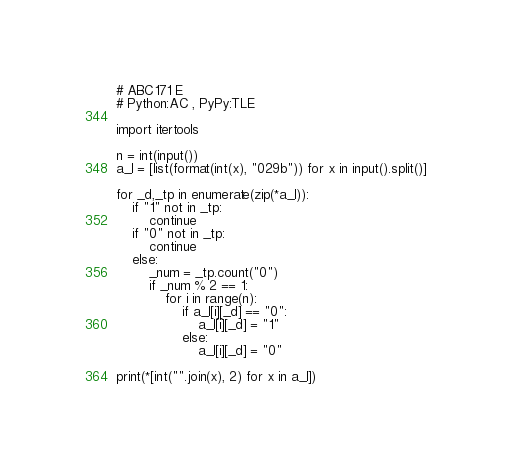Convert code to text. <code><loc_0><loc_0><loc_500><loc_500><_Python_># ABC171 E 
# Python:AC , PyPy:TLE

import itertools

n = int(input())
a_l = [list(format(int(x), "029b")) for x in input().split()]

for _d,_tp in enumerate(zip(*a_l)):
    if "1" not in _tp:
        continue
    if "0" not in _tp:
        continue
    else:
        _num = _tp.count("0")
        if _num % 2 == 1:
            for i in range(n):
                if a_l[i][_d] == "0":
                    a_l[i][_d] = "1"
                else:
                    a_l[i][_d] = "0"

print(*[int("".join(x), 2) for x in a_l])</code> 